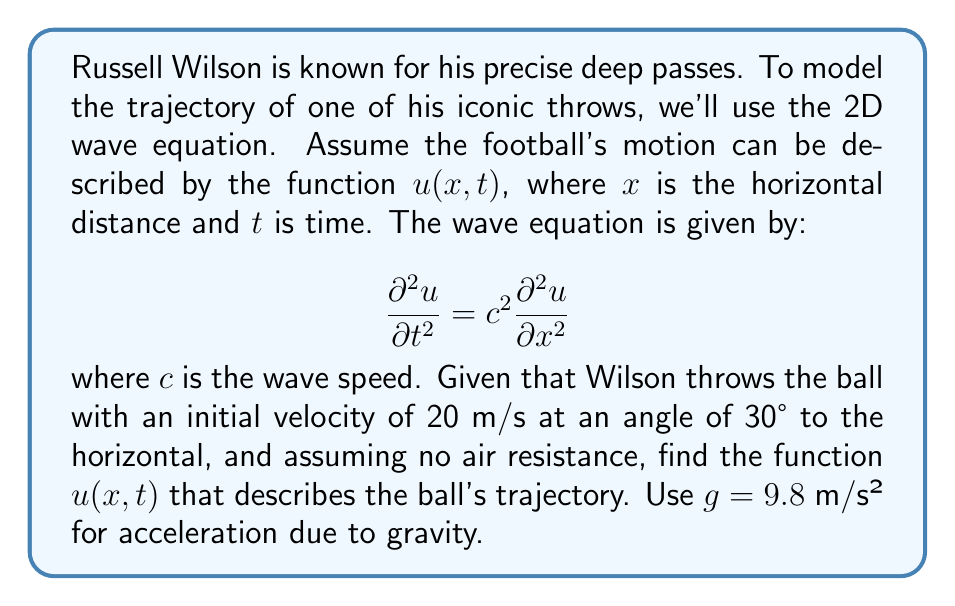Give your solution to this math problem. To solve this problem, we'll follow these steps:

1) First, we need to recognize that the trajectory of the football doesn't actually follow the wave equation. Instead, it follows a parabolic path due to projectile motion. However, we can use the wave equation to model the vertical component of the motion.

2) The general solution to the 1D wave equation is:

   $u(x,t) = f(x-ct) + g(x+ct)$

   where $f$ and $g$ are arbitrary functions.

3) In our case, we're only interested in the forward-moving wave, so we can simplify to:

   $u(x,t) = f(x-ct)$

4) Now, we need to determine the function $f$. For a projectile, the vertical position $y$ as a function of time $t$ is given by:

   $y(t) = v_0\sin(\theta)t - \frac{1}{2}gt^2$

   where $v_0$ is the initial velocity and $\theta$ is the launch angle.

5) We can relate $x$ and $t$ using the horizontal component of velocity:

   $x = v_0\cos(\theta)t$

   Solving for $t$:

   $t = \frac{x}{v_0\cos(\theta)}$

6) Substituting this into our equation for $y(t)$:

   $y(x) = \tan(\theta)x - \frac{g}{2(v_0\cos(\theta))^2}x^2$

7) This gives us our function $f$:

   $f(x) = \tan(30°)x - \frac{9.8}{2(20\cos(30°))^2}x^2$

8) Therefore, our solution is:

   $u(x,t) = \frac{1}{\sqrt{3}}(x-ct) - \frac{9.8}{2(20\cos(30°))^2}(x-ct)^2$

9) To determine $c$, we can use the horizontal component of velocity:

   $c = v_0\cos(\theta) = 20\cos(30°) \approx 17.32$ m/s

10) Our final solution is:

    $u(x,t) = \frac{1}{\sqrt{3}}(x-17.32t) - 0.0065(x-17.32t)^2$
Answer: $u(x,t) = \frac{1}{\sqrt{3}}(x-17.32t) - 0.0065(x-17.32t)^2$ 